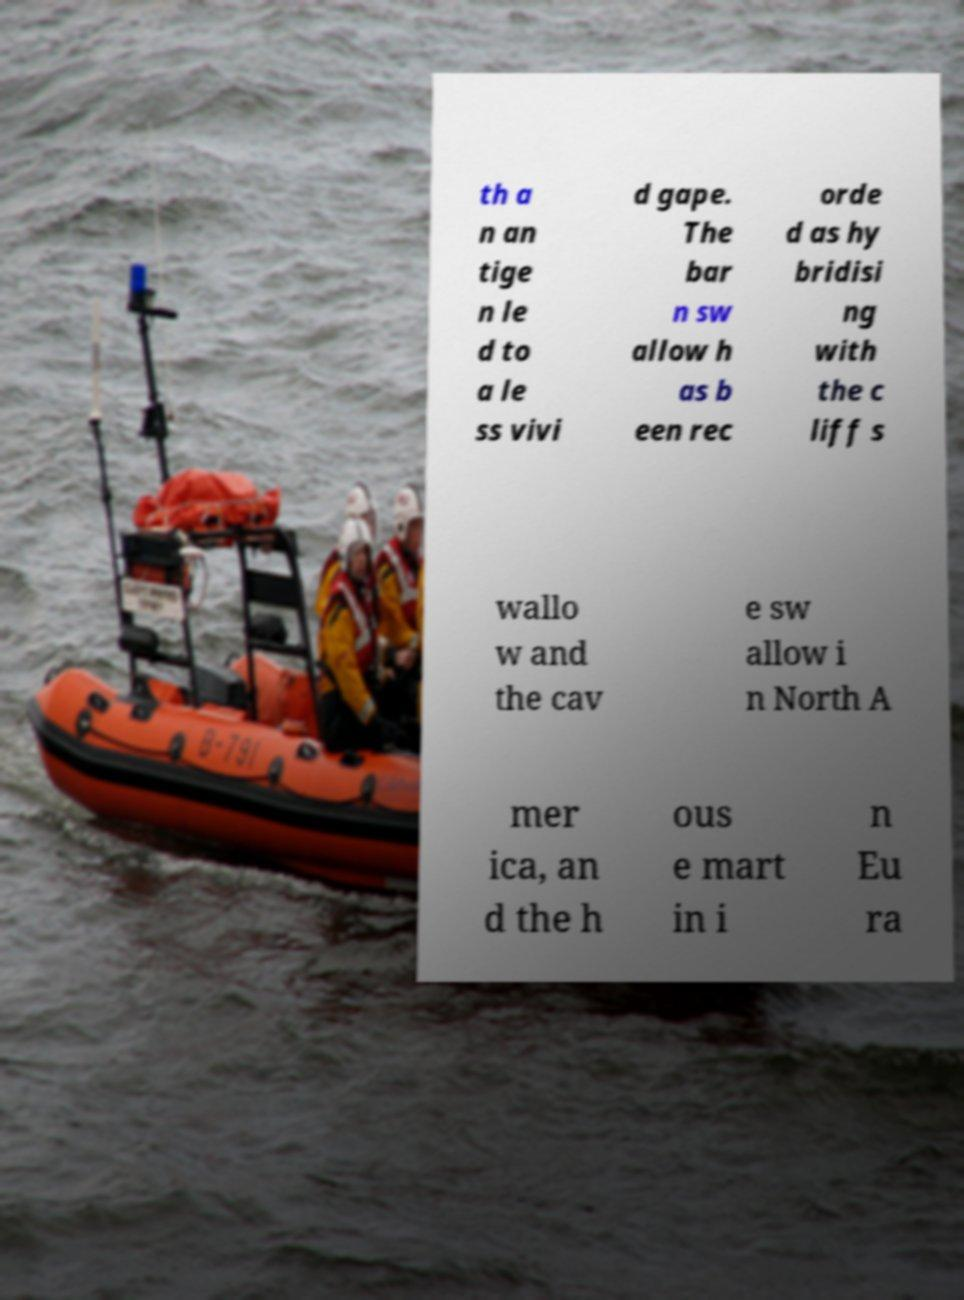Can you read and provide the text displayed in the image?This photo seems to have some interesting text. Can you extract and type it out for me? th a n an tige n le d to a le ss vivi d gape. The bar n sw allow h as b een rec orde d as hy bridisi ng with the c liff s wallo w and the cav e sw allow i n North A mer ica, an d the h ous e mart in i n Eu ra 